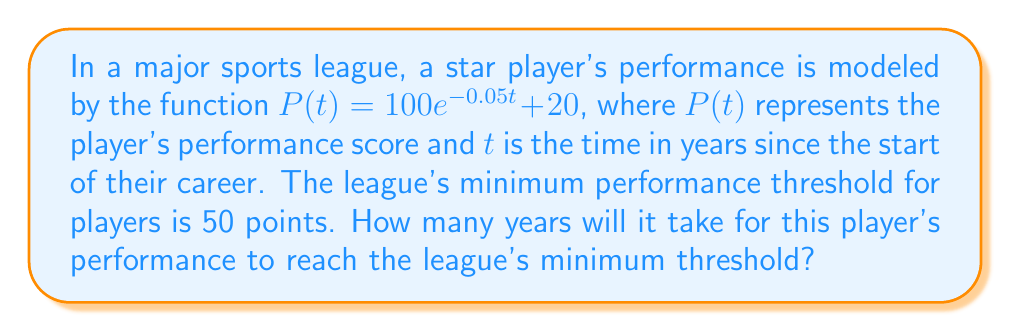Show me your answer to this math problem. To solve this problem, we need to use the exponential decay model and solve for t when P(t) = 50.

1) We start with the given equation:
   $P(t) = 100e^{-0.05t} + 20$

2) We want to find t when P(t) = 50, so we set up the equation:
   $50 = 100e^{-0.05t} + 20$

3) Subtract 20 from both sides:
   $30 = 100e^{-0.05t}$

4) Divide both sides by 100:
   $0.3 = e^{-0.05t}$

5) Take the natural logarithm of both sides:
   $\ln(0.3) = \ln(e^{-0.05t})$

6) Simplify the right side using the properties of logarithms:
   $\ln(0.3) = -0.05t$

7) Divide both sides by -0.05:
   $\frac{\ln(0.3)}{-0.05} = t$

8) Calculate the value:
   $t \approx 24.08$ years

Therefore, it will take approximately 24.08 years for the player's performance to reach the league's minimum threshold.
Answer: $24.08$ years 